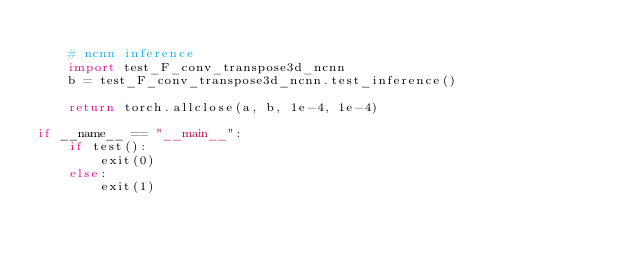Convert code to text. <code><loc_0><loc_0><loc_500><loc_500><_Python_>
    # ncnn inference
    import test_F_conv_transpose3d_ncnn
    b = test_F_conv_transpose3d_ncnn.test_inference()

    return torch.allclose(a, b, 1e-4, 1e-4)

if __name__ == "__main__":
    if test():
        exit(0)
    else:
        exit(1)
</code> 